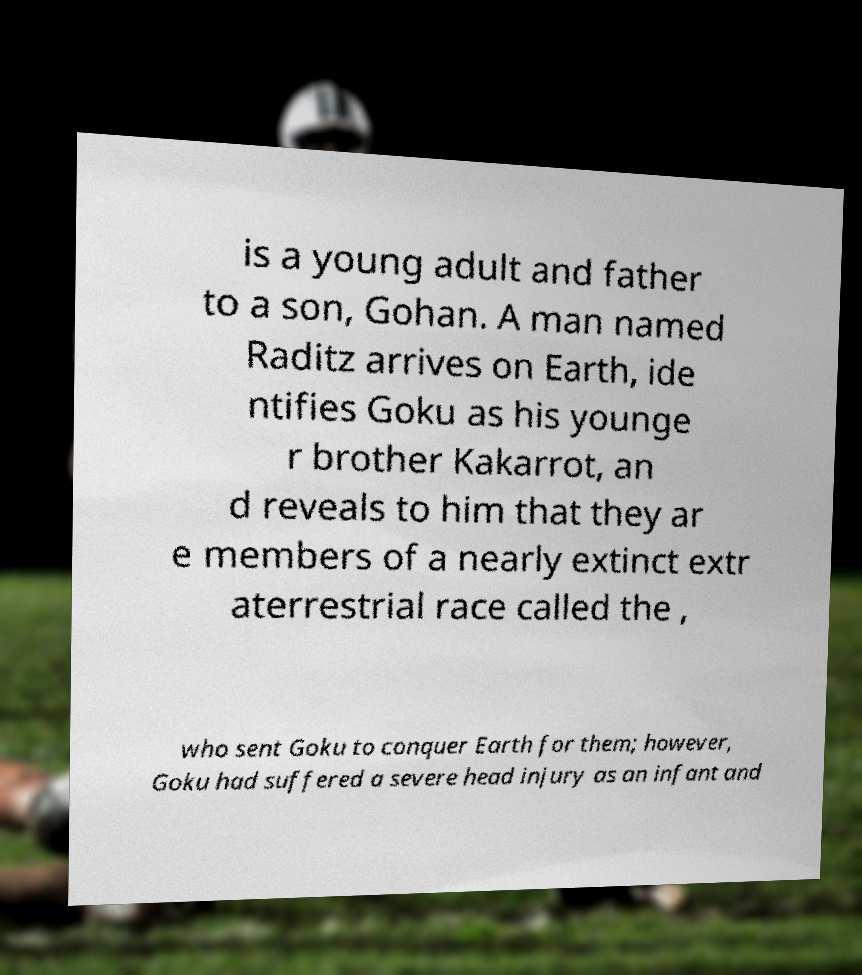Could you assist in decoding the text presented in this image and type it out clearly? is a young adult and father to a son, Gohan. A man named Raditz arrives on Earth, ide ntifies Goku as his younge r brother Kakarrot, an d reveals to him that they ar e members of a nearly extinct extr aterrestrial race called the , who sent Goku to conquer Earth for them; however, Goku had suffered a severe head injury as an infant and 